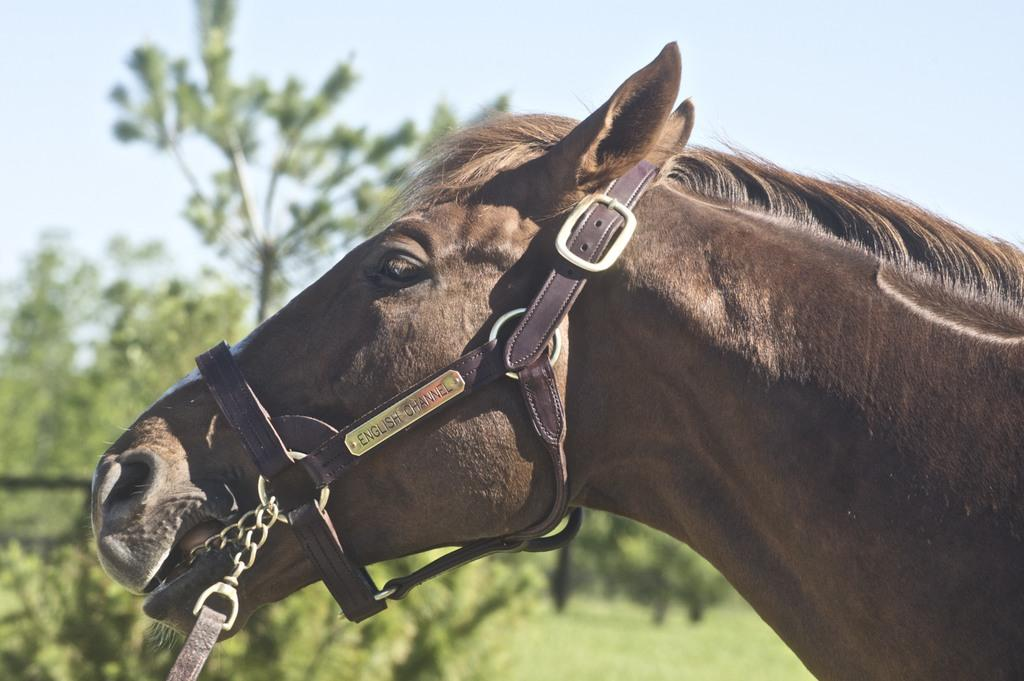What animal is present in the image? There is a horse in the image. What type of accessory can be seen in the image? There are belts in the image. What can be seen in the background of the image? There are trees in the background of the image. What type of zinc is present in the image? There is no zinc present in the image. How many mice can be seen in the image? There are no mice present in the image. 